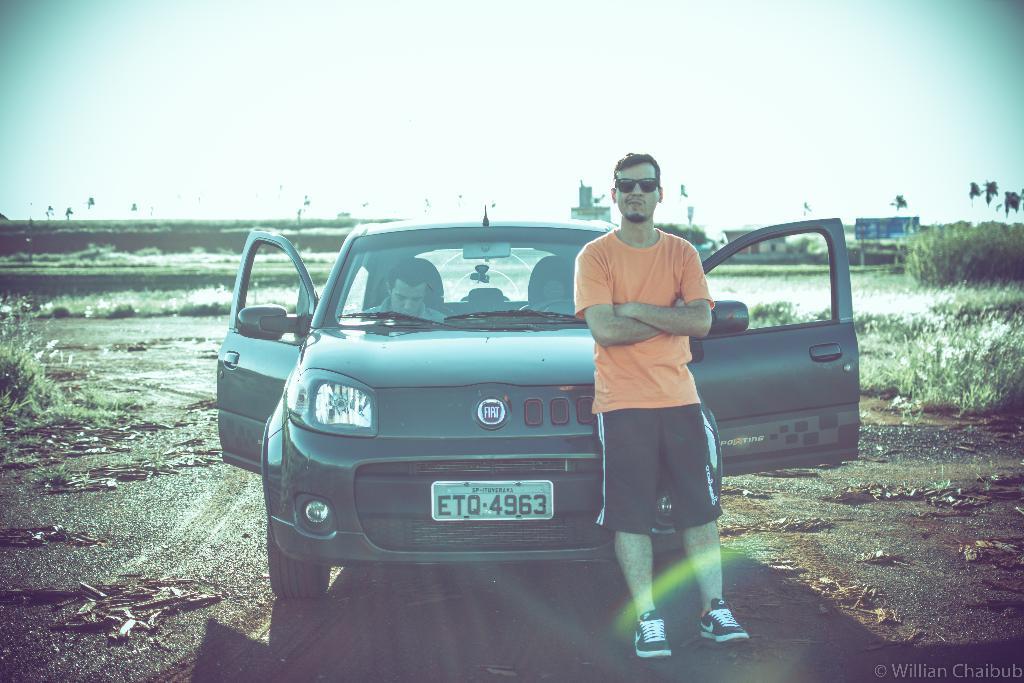Describe this image in one or two sentences. In this picture we can see man wore orange color T-Shirt, goggle, shoes and standing beside to him we can see cars where doors are opened and man is sitting inside the car and in background we can see trees, sky, banner, path. 